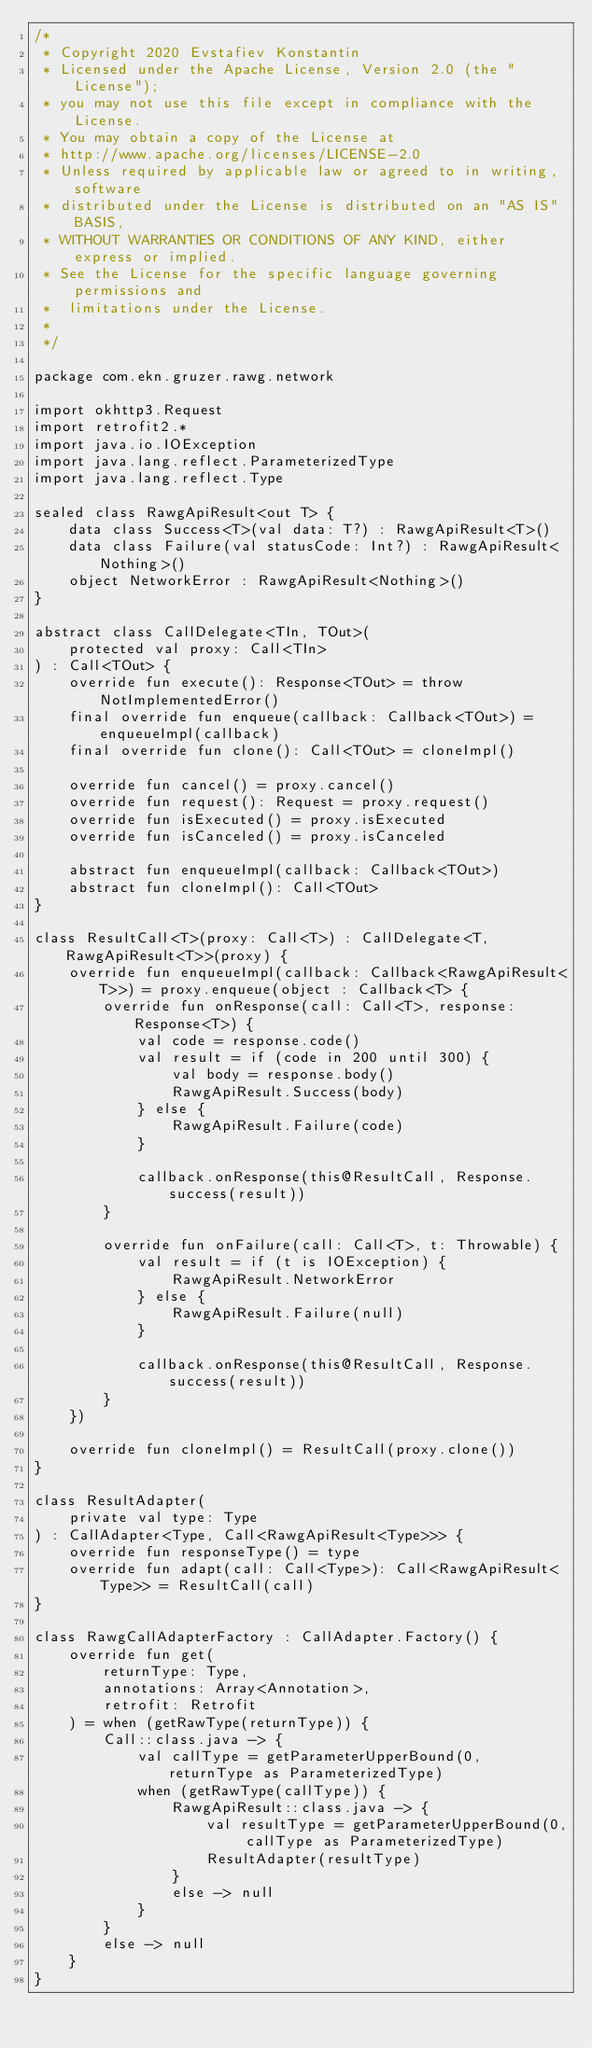Convert code to text. <code><loc_0><loc_0><loc_500><loc_500><_Kotlin_>/*
 * Copyright 2020 Evstafiev Konstantin
 * Licensed under the Apache License, Version 2.0 (the "License");
 * you may not use this file except in compliance with the License.
 * You may obtain a copy of the License at
 * http://www.apache.org/licenses/LICENSE-2.0
 * Unless required by applicable law or agreed to in writing, software
 * distributed under the License is distributed on an "AS IS" BASIS,
 * WITHOUT WARRANTIES OR CONDITIONS OF ANY KIND, either express or implied.
 * See the License for the specific language governing permissions and
 *  limitations under the License.
 *
 */

package com.ekn.gruzer.rawg.network

import okhttp3.Request
import retrofit2.*
import java.io.IOException
import java.lang.reflect.ParameterizedType
import java.lang.reflect.Type

sealed class RawgApiResult<out T> {
    data class Success<T>(val data: T?) : RawgApiResult<T>()
    data class Failure(val statusCode: Int?) : RawgApiResult<Nothing>()
    object NetworkError : RawgApiResult<Nothing>()
}

abstract class CallDelegate<TIn, TOut>(
    protected val proxy: Call<TIn>
) : Call<TOut> {
    override fun execute(): Response<TOut> = throw NotImplementedError()
    final override fun enqueue(callback: Callback<TOut>) = enqueueImpl(callback)
    final override fun clone(): Call<TOut> = cloneImpl()

    override fun cancel() = proxy.cancel()
    override fun request(): Request = proxy.request()
    override fun isExecuted() = proxy.isExecuted
    override fun isCanceled() = proxy.isCanceled

    abstract fun enqueueImpl(callback: Callback<TOut>)
    abstract fun cloneImpl(): Call<TOut>
}

class ResultCall<T>(proxy: Call<T>) : CallDelegate<T, RawgApiResult<T>>(proxy) {
    override fun enqueueImpl(callback: Callback<RawgApiResult<T>>) = proxy.enqueue(object : Callback<T> {
        override fun onResponse(call: Call<T>, response: Response<T>) {
            val code = response.code()
            val result = if (code in 200 until 300) {
                val body = response.body()
                RawgApiResult.Success(body)
            } else {
                RawgApiResult.Failure(code)
            }

            callback.onResponse(this@ResultCall, Response.success(result))
        }

        override fun onFailure(call: Call<T>, t: Throwable) {
            val result = if (t is IOException) {
                RawgApiResult.NetworkError
            } else {
                RawgApiResult.Failure(null)
            }

            callback.onResponse(this@ResultCall, Response.success(result))
        }
    })

    override fun cloneImpl() = ResultCall(proxy.clone())
}

class ResultAdapter(
    private val type: Type
) : CallAdapter<Type, Call<RawgApiResult<Type>>> {
    override fun responseType() = type
    override fun adapt(call: Call<Type>): Call<RawgApiResult<Type>> = ResultCall(call)
}

class RawgCallAdapterFactory : CallAdapter.Factory() {
    override fun get(
        returnType: Type,
        annotations: Array<Annotation>,
        retrofit: Retrofit
    ) = when (getRawType(returnType)) {
        Call::class.java -> {
            val callType = getParameterUpperBound(0, returnType as ParameterizedType)
            when (getRawType(callType)) {
                RawgApiResult::class.java -> {
                    val resultType = getParameterUpperBound(0, callType as ParameterizedType)
                    ResultAdapter(resultType)
                }
                else -> null
            }
        }
        else -> null
    }
}</code> 